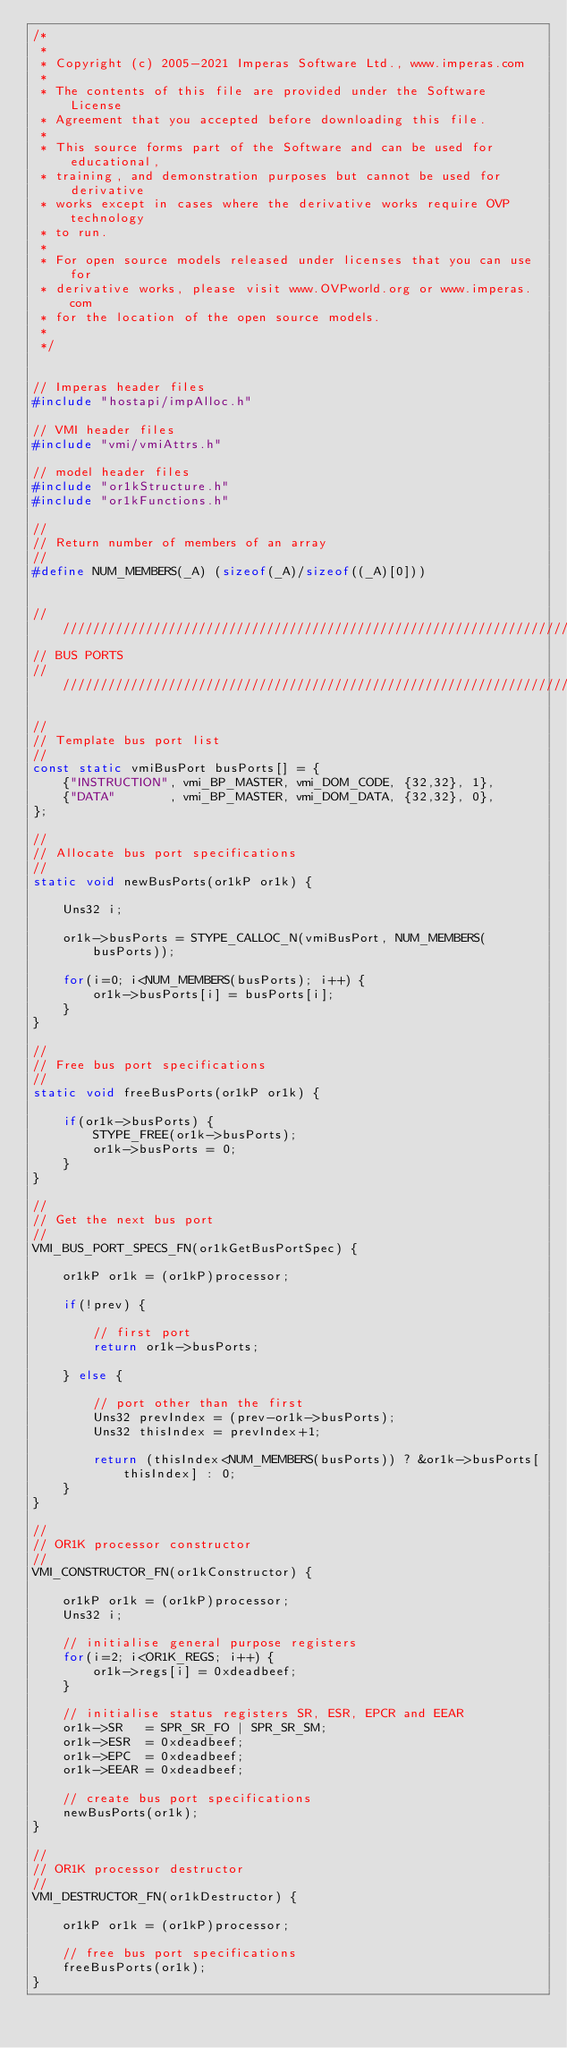<code> <loc_0><loc_0><loc_500><loc_500><_C_>/*
 *
 * Copyright (c) 2005-2021 Imperas Software Ltd., www.imperas.com
 *
 * The contents of this file are provided under the Software License
 * Agreement that you accepted before downloading this file.
 *
 * This source forms part of the Software and can be used for educational,
 * training, and demonstration purposes but cannot be used for derivative
 * works except in cases where the derivative works require OVP technology
 * to run.
 *
 * For open source models released under licenses that you can use for
 * derivative works, please visit www.OVPworld.org or www.imperas.com
 * for the location of the open source models.
 *
 */


// Imperas header files
#include "hostapi/impAlloc.h"

// VMI header files
#include "vmi/vmiAttrs.h"

// model header files
#include "or1kStructure.h"
#include "or1kFunctions.h"

//
// Return number of members of an array
//
#define NUM_MEMBERS(_A) (sizeof(_A)/sizeof((_A)[0]))


////////////////////////////////////////////////////////////////////////////////
// BUS PORTS
////////////////////////////////////////////////////////////////////////////////

//
// Template bus port list
//
const static vmiBusPort busPorts[] = {
    {"INSTRUCTION", vmi_BP_MASTER, vmi_DOM_CODE, {32,32}, 1},
    {"DATA"       , vmi_BP_MASTER, vmi_DOM_DATA, {32,32}, 0},
};

//
// Allocate bus port specifications
//
static void newBusPorts(or1kP or1k) {

    Uns32 i;

    or1k->busPorts = STYPE_CALLOC_N(vmiBusPort, NUM_MEMBERS(busPorts));

    for(i=0; i<NUM_MEMBERS(busPorts); i++) {
        or1k->busPorts[i] = busPorts[i];
    }
}

//
// Free bus port specifications
//
static void freeBusPorts(or1kP or1k) {

    if(or1k->busPorts) {
        STYPE_FREE(or1k->busPorts);
        or1k->busPorts = 0;
    }
}

//
// Get the next bus port
//
VMI_BUS_PORT_SPECS_FN(or1kGetBusPortSpec) {

    or1kP or1k = (or1kP)processor;

    if(!prev) {

        // first port
        return or1k->busPorts;

    } else {

        // port other than the first
        Uns32 prevIndex = (prev-or1k->busPorts);
        Uns32 thisIndex = prevIndex+1;

        return (thisIndex<NUM_MEMBERS(busPorts)) ? &or1k->busPorts[thisIndex] : 0;
    }
}

//
// OR1K processor constructor
//
VMI_CONSTRUCTOR_FN(or1kConstructor) {

    or1kP or1k = (or1kP)processor;
    Uns32 i;

    // initialise general purpose registers
    for(i=2; i<OR1K_REGS; i++) {
        or1k->regs[i] = 0xdeadbeef;
    }

    // initialise status registers SR, ESR, EPCR and EEAR
    or1k->SR   = SPR_SR_FO | SPR_SR_SM;
    or1k->ESR  = 0xdeadbeef;
    or1k->EPC  = 0xdeadbeef;
    or1k->EEAR = 0xdeadbeef;

    // create bus port specifications
    newBusPorts(or1k);
}

//
// OR1K processor destructor
//
VMI_DESTRUCTOR_FN(or1kDestructor) {

    or1kP or1k = (or1kP)processor;

    // free bus port specifications
    freeBusPorts(or1k);
}

</code> 